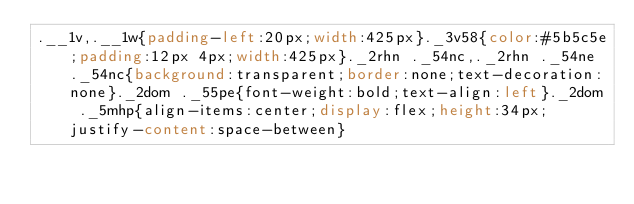Convert code to text. <code><loc_0><loc_0><loc_500><loc_500><_CSS_>.__1v,.__1w{padding-left:20px;width:425px}._3v58{color:#5b5c5e;padding:12px 4px;width:425px}._2rhn ._54nc,._2rhn ._54ne ._54nc{background:transparent;border:none;text-decoration:none}._2dom ._55pe{font-weight:bold;text-align:left}._2dom ._5mhp{align-items:center;display:flex;height:34px;justify-content:space-between}</code> 